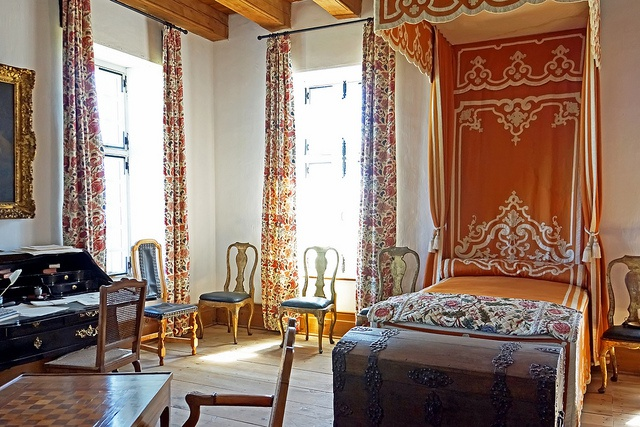Describe the objects in this image and their specific colors. I can see bed in darkgray, black, gray, and maroon tones, chair in darkgray, gray, black, and maroon tones, chair in darkgray, maroon, gray, and brown tones, chair in darkgray, gray, maroon, and black tones, and chair in darkgray, white, tan, and olive tones in this image. 